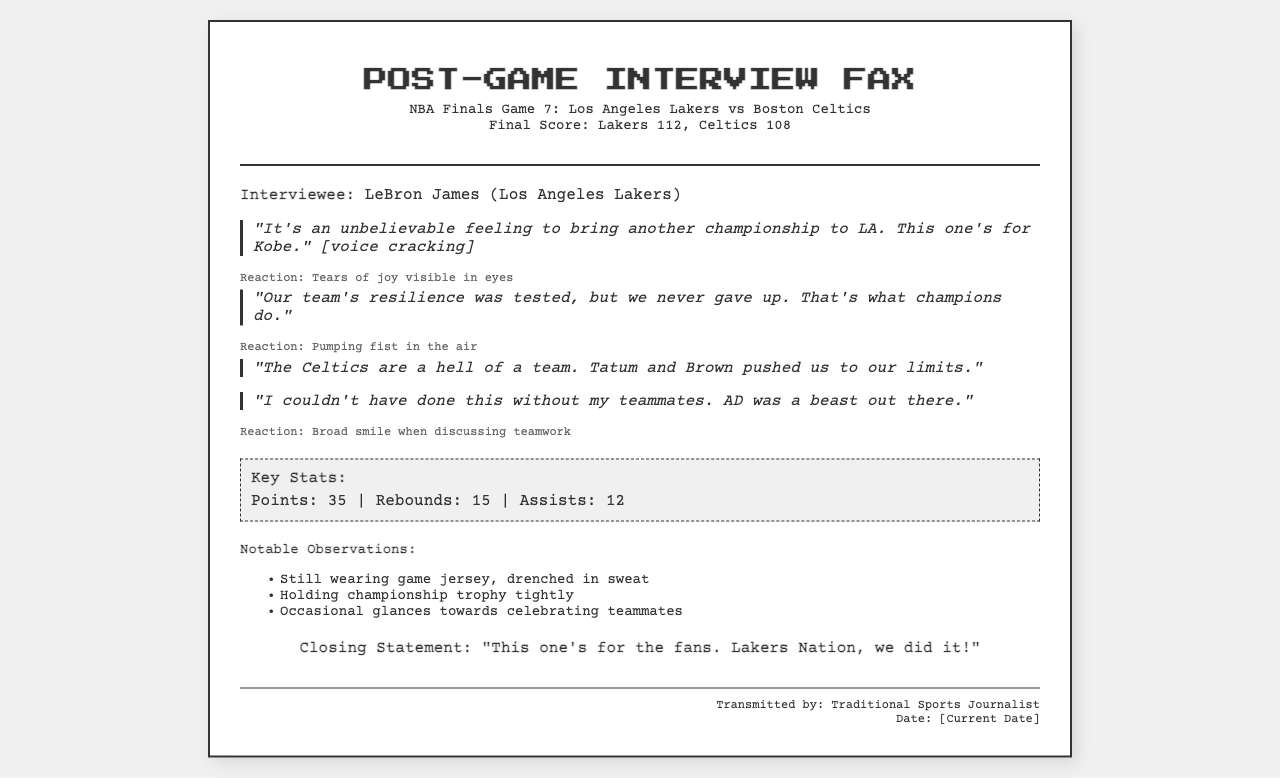What was the final score of the game? The final score is clearly stated in the document as the outcome of NBA Finals Game 7.
Answer: Lakers 112, Celtics 108 Who is the interviewee? The document specifies the individual being interviewed after the game.
Answer: LeBron James What quote mentions Kobe? The document contains a specific quote from the athlete that refers to Kobe.
Answer: "This one's for Kobe." How many points did LeBron James score? The document includes key statistics that highlight the athlete's performance in the game.
Answer: 35 What was LeBron's reaction when discussing teamwork? The document describes LeBron's emotional reaction when he talked about his teammates.
Answer: Broad smile What is the notable observation about LeBron's attire? The document includes an observation regarding LeBron's appearance immediately post-game.
Answer: Still wearing game jersey What was the closing statement from LeBron? The document includes a specific concluding remark made by LeBron at the end of the interview.
Answer: "This one's for the fans. Lakers Nation, we did it!" Which team did the Lakers compete against? The document mentions the opposing team in the game.
Answer: Boston Celtics How many rebounds did LeBron James have? The document provides performance statistics, including the number of rebounds.
Answer: 15 